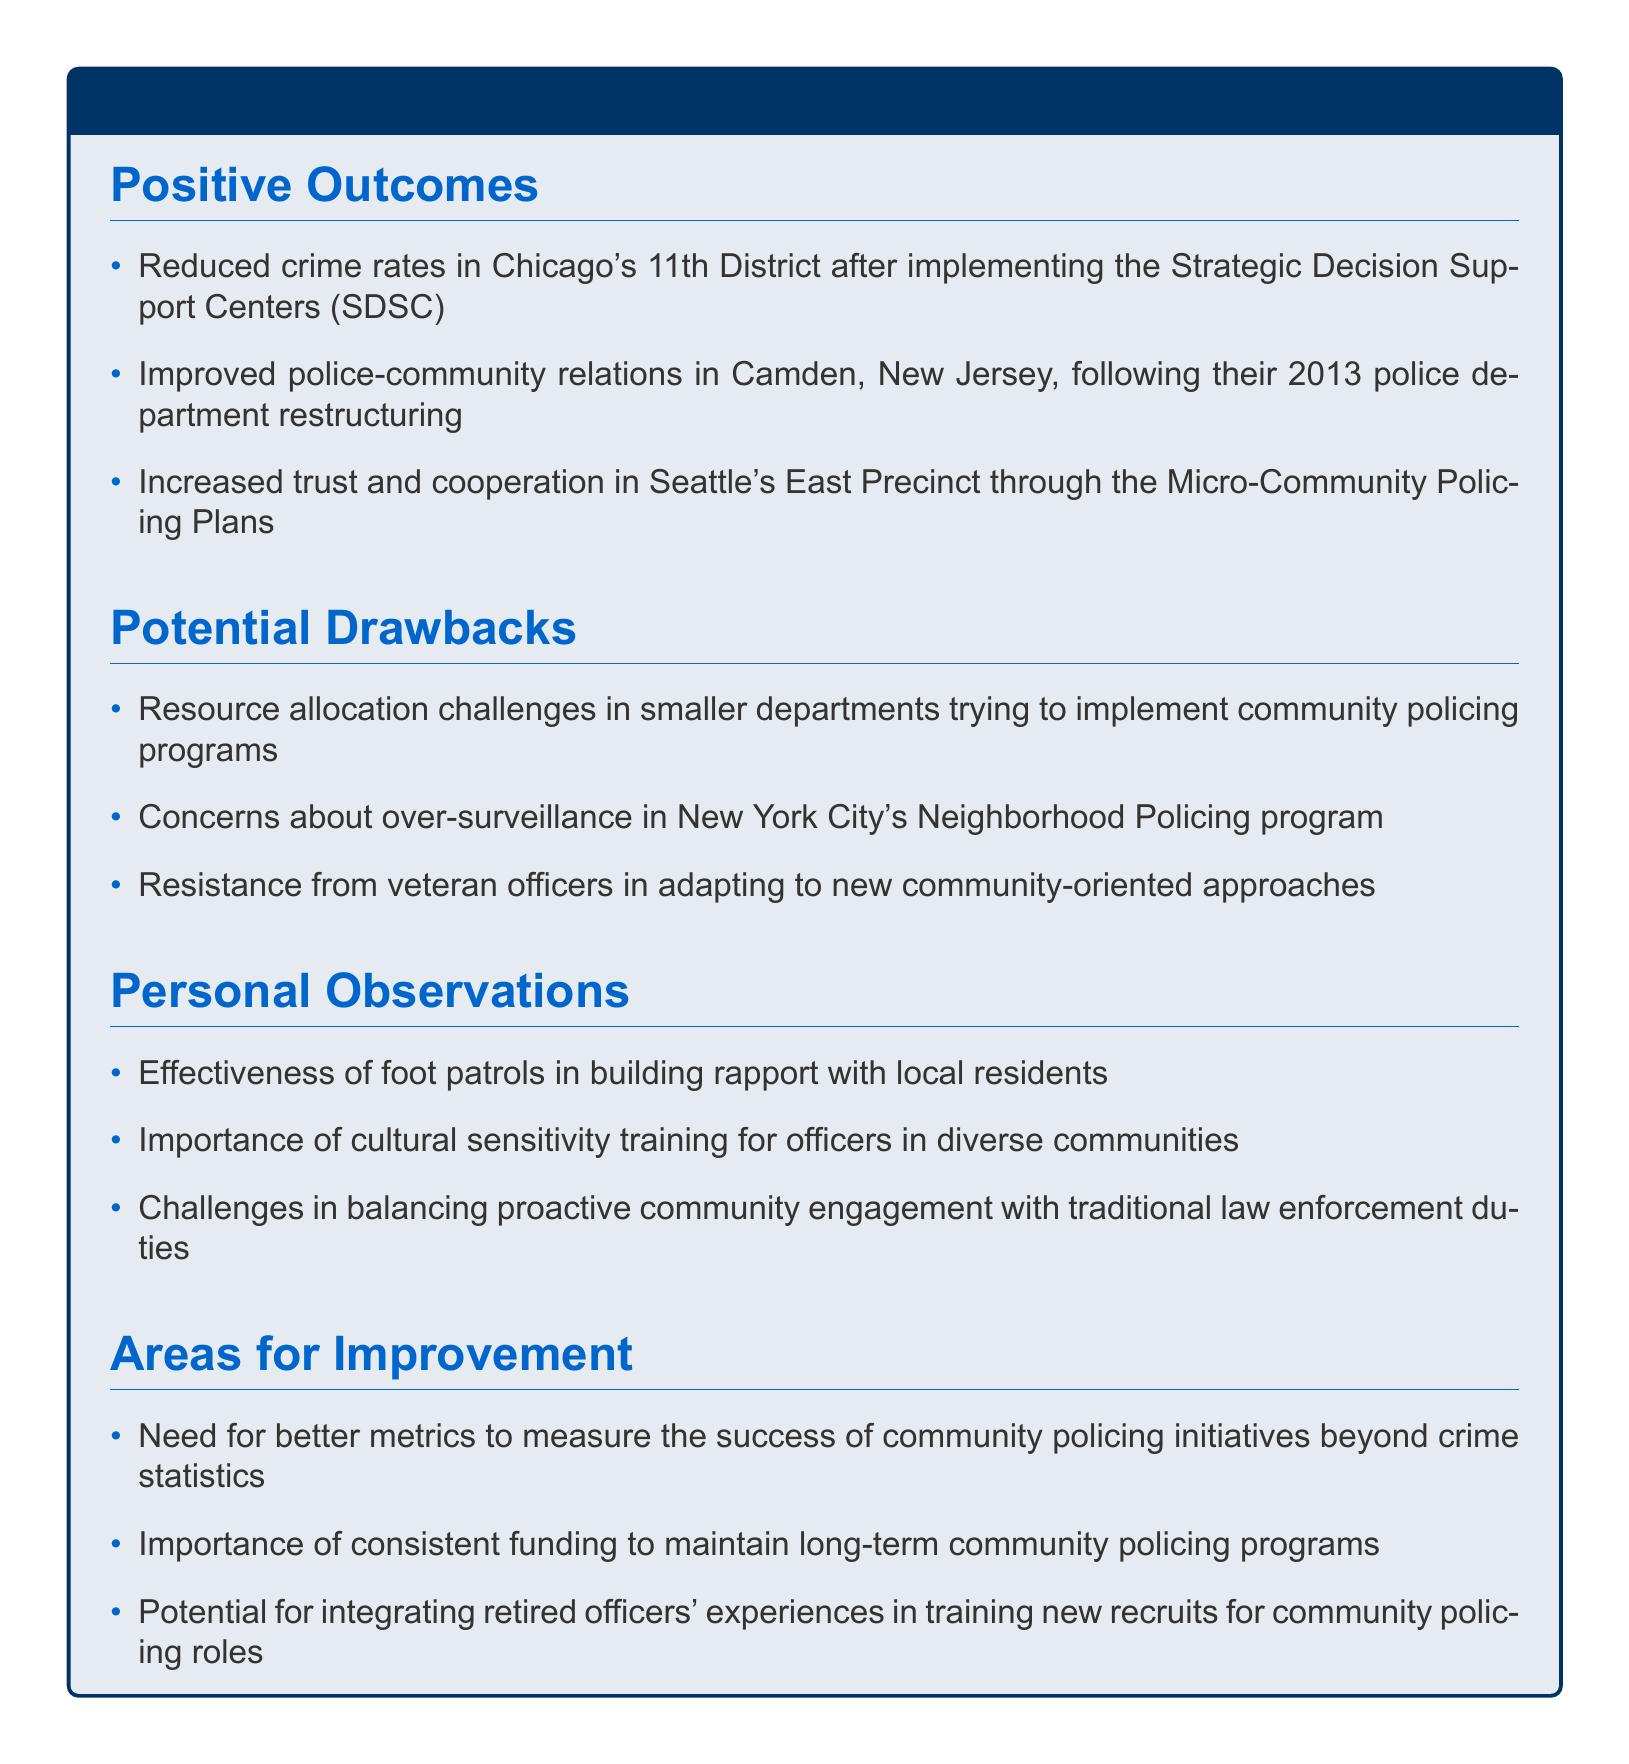What is one positive outcome from community policing initiatives? The document lists several positive outcomes of community policing, such as reduced crime rates in specific districts.
Answer: Reduced crime rates in Chicago's 11th District after implementing the Strategic Decision Support Centers What concern is associated with New York City's Neighborhood Policing program? The document mentions potential drawbacks, including concerns regarding surveillance.
Answer: Over-surveillance Which city showed improved police-community relations after a restructuring in 2013? The document specifies the city where community relations improved post-restructuring.
Answer: Camden, New Jersey What is emphasized as a necessary training for officers in diverse communities? The document highlights the need for specific training to enhance officer effectiveness in various cultural settings.
Answer: Cultural sensitivity training What area for improvement suggests integrating retired officers' experiences? The document notes potential benefits from utilizing the experiences of retired officers in the training process.
Answer: Training new recruits for community policing roles 